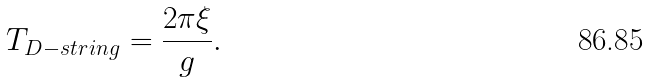<formula> <loc_0><loc_0><loc_500><loc_500>T _ { D - s t r i n g } = \frac { 2 \pi \xi } { g } .</formula> 